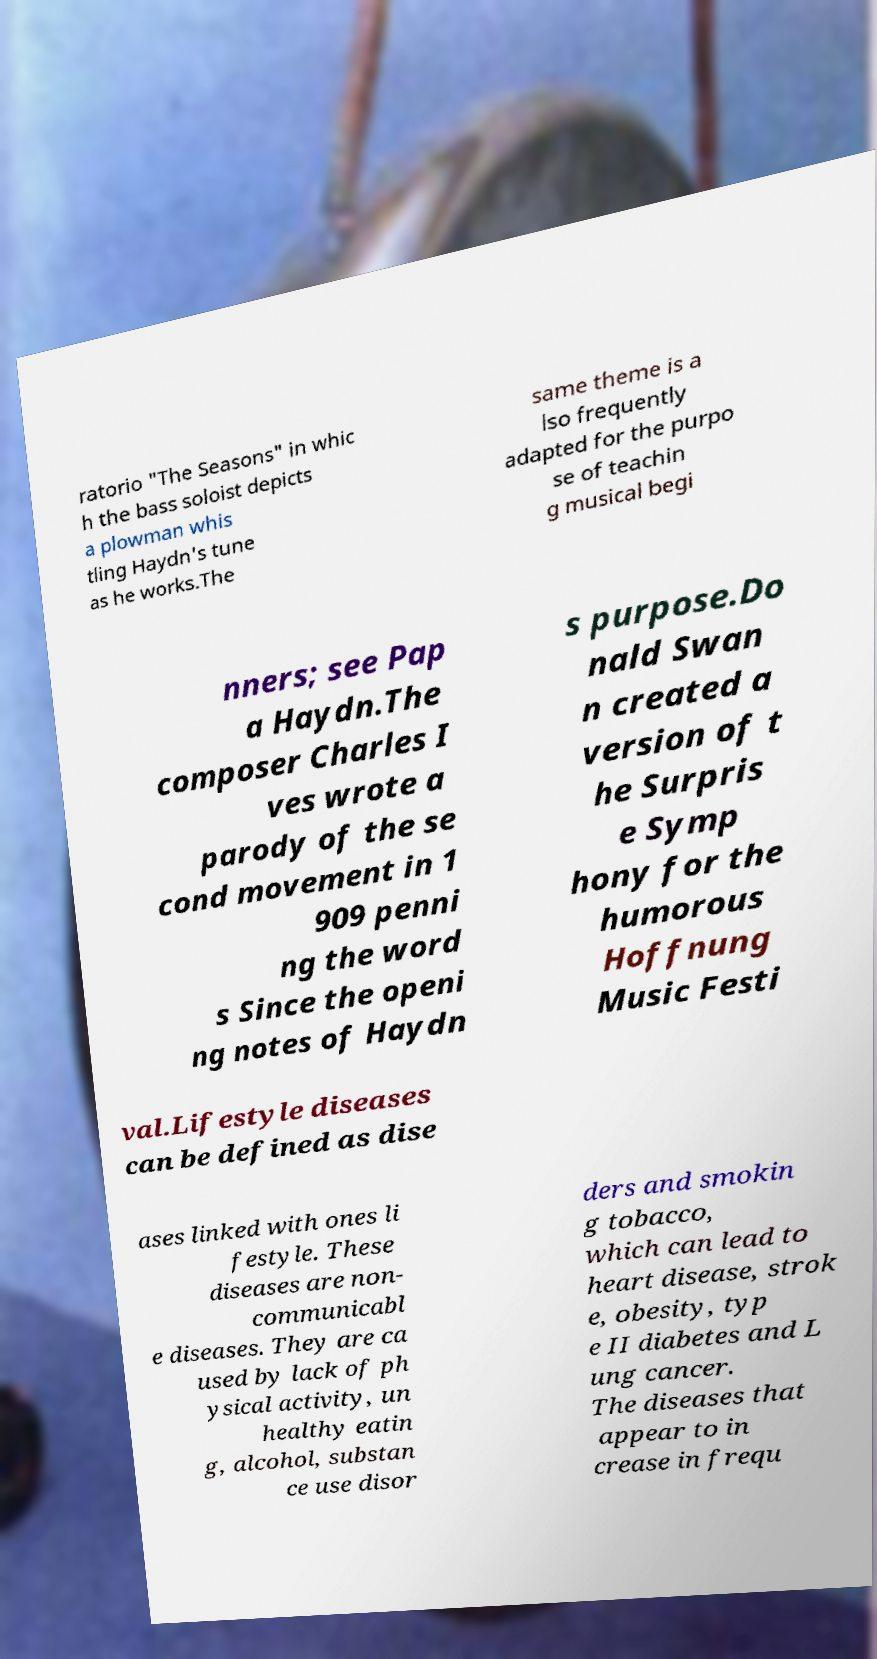Could you assist in decoding the text presented in this image and type it out clearly? ratorio "The Seasons" in whic h the bass soloist depicts a plowman whis tling Haydn's tune as he works.The same theme is a lso frequently adapted for the purpo se of teachin g musical begi nners; see Pap a Haydn.The composer Charles I ves wrote a parody of the se cond movement in 1 909 penni ng the word s Since the openi ng notes of Haydn s purpose.Do nald Swan n created a version of t he Surpris e Symp hony for the humorous Hoffnung Music Festi val.Lifestyle diseases can be defined as dise ases linked with ones li festyle. These diseases are non- communicabl e diseases. They are ca used by lack of ph ysical activity, un healthy eatin g, alcohol, substan ce use disor ders and smokin g tobacco, which can lead to heart disease, strok e, obesity, typ e II diabetes and L ung cancer. The diseases that appear to in crease in frequ 